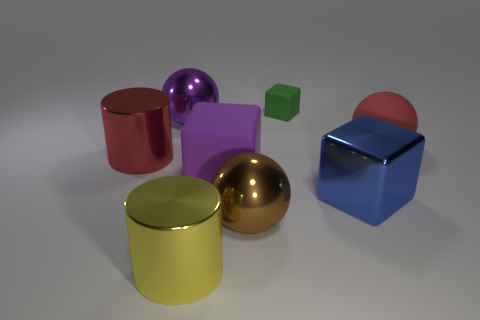What shape is the big shiny thing that is the same color as the rubber ball?
Ensure brevity in your answer.  Cylinder. There is a purple thing that is the same material as the large yellow object; what size is it?
Your answer should be compact. Large. What shape is the large thing that is behind the blue block and to the right of the green rubber block?
Offer a very short reply. Sphere. There is a metallic sphere to the right of the yellow cylinder; does it have the same color as the small rubber block?
Make the answer very short. No. Do the purple thing that is behind the large red metallic object and the red object that is to the right of the big metallic cube have the same shape?
Give a very brief answer. Yes. What size is the brown shiny object to the left of the large blue cube?
Your answer should be very brief. Large. What is the size of the metallic ball that is on the right side of the large rubber thing on the left side of the large blue shiny cube?
Offer a very short reply. Large. Are there more objects than tiny gray metal things?
Ensure brevity in your answer.  Yes. Is the number of shiny balls behind the big brown thing greater than the number of large red cylinders that are in front of the yellow metal thing?
Make the answer very short. Yes. How big is the thing that is right of the large brown ball and in front of the large purple rubber thing?
Give a very brief answer. Large. 